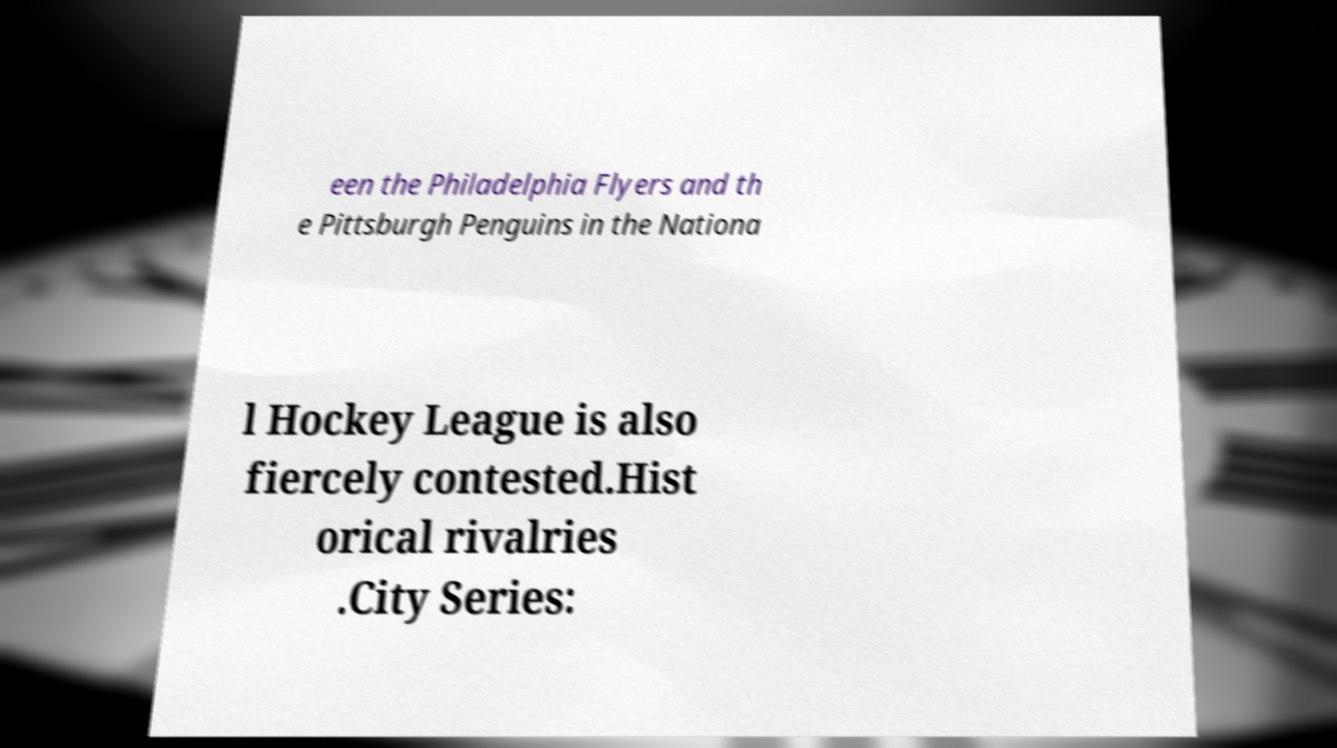Can you accurately transcribe the text from the provided image for me? een the Philadelphia Flyers and th e Pittsburgh Penguins in the Nationa l Hockey League is also fiercely contested.Hist orical rivalries .City Series: 